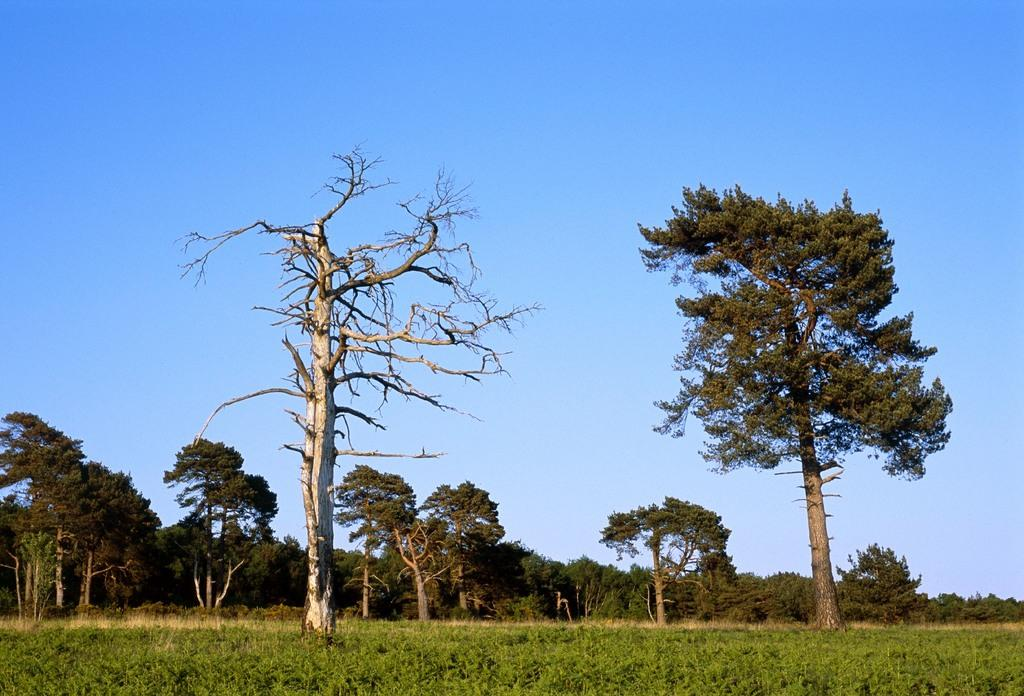What type of vegetation can be seen in the image? There is a group of trees and plants visible in the image. Can you describe the condition of one of the trees? One of the trees has dried branches. What is visible in the background of the image? The sky is visible in the image. How would you describe the weather based on the sky? The sky appears to be cloudy, which might suggest overcast or potentially rainy weather. What type of meat is being cooked on the stone in the image? There is no meat or stone present in the image; it features a group of trees, plants, and a cloudy sky. 